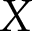Convert formula to latex. <formula><loc_0><loc_0><loc_500><loc_500>X</formula> 